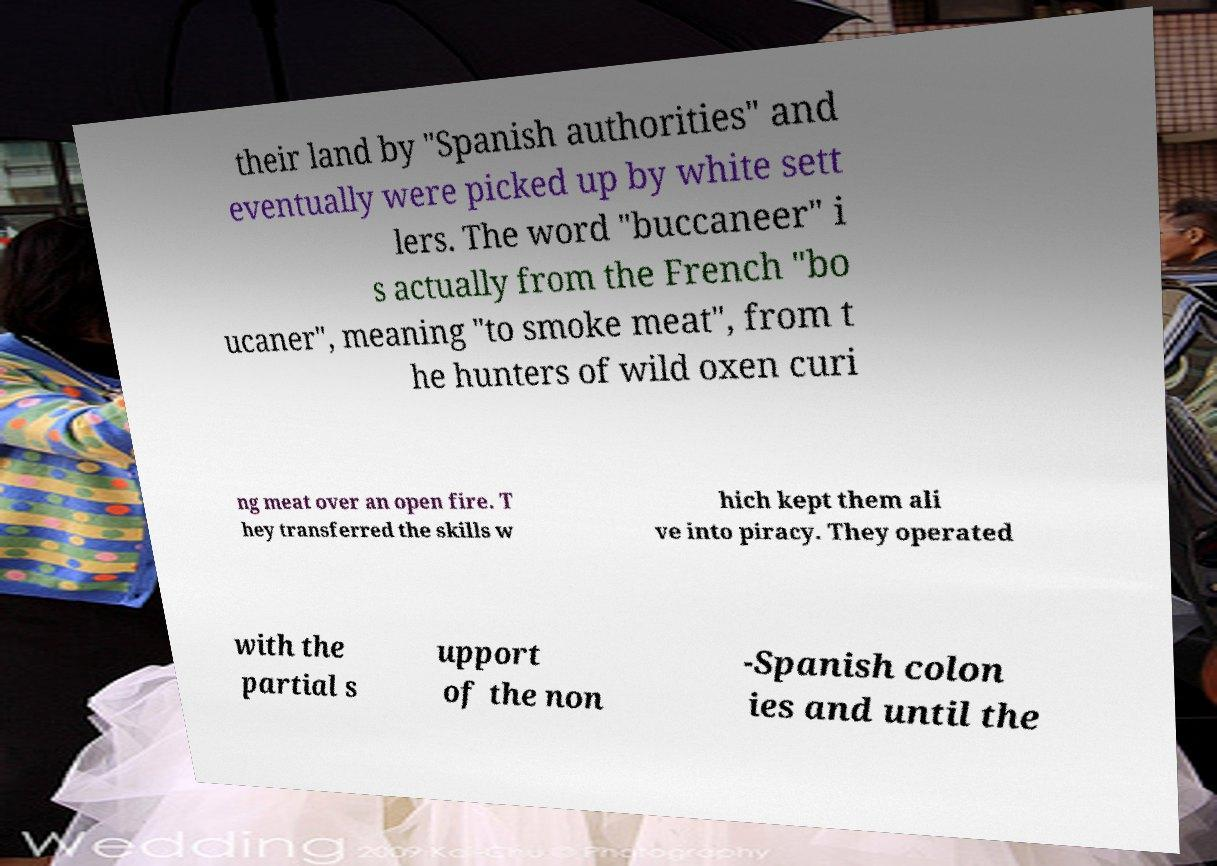Could you extract and type out the text from this image? their land by "Spanish authorities" and eventually were picked up by white sett lers. The word "buccaneer" i s actually from the French "bo ucaner", meaning "to smoke meat", from t he hunters of wild oxen curi ng meat over an open fire. T hey transferred the skills w hich kept them ali ve into piracy. They operated with the partial s upport of the non -Spanish colon ies and until the 